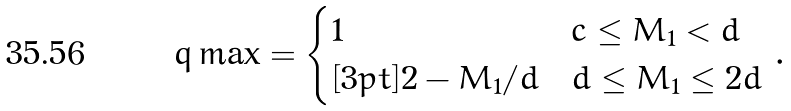Convert formula to latex. <formula><loc_0><loc_0><loc_500><loc_500>\ q \max = \begin{cases} 1 & c \leq M _ { 1 } < d \\ [ 3 p t ] 2 - M _ { 1 } / d & d \leq M _ { 1 } \leq 2 d \end{cases} \, .</formula> 